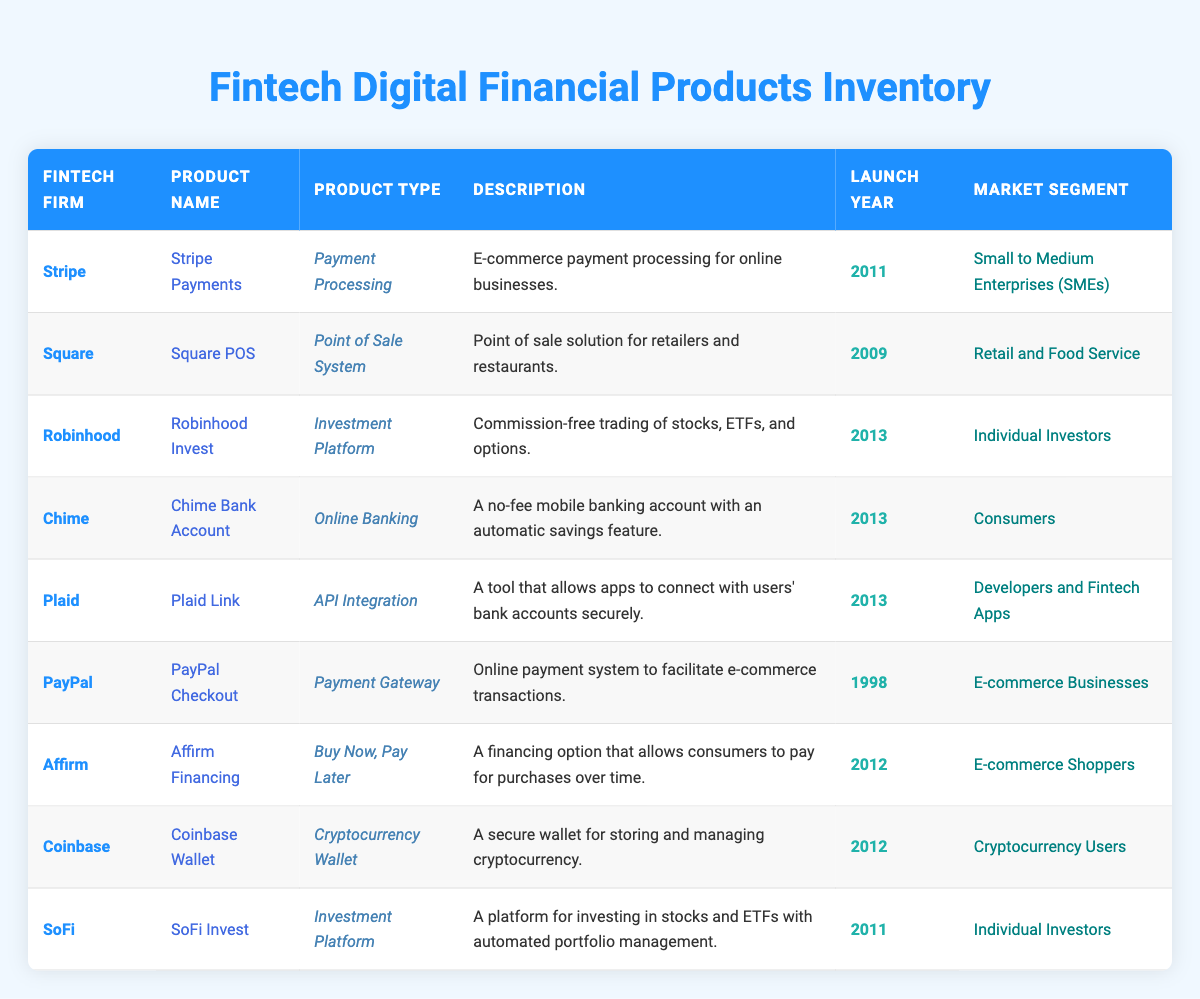What is the product type of Stripe's offering? There is one row for Stripe in the table. In that row, the "Product Type" column indicates "Payment Processing."
Answer: Payment Processing Which fintech firms offer investment platforms? The table contains two rows where the "Product Type" is "Investment Platform": Robinhood and SoFi.
Answer: Robinhood, SoFi How many products were launched in 2013? The table shows products launched in 2013 for Robinhood Invest, Chime Bank Account, and Plaid Link. Therefore, there are three products launched in that year.
Answer: 3 Is PayPal Checkout targeted towards individual investors? The table shows that "PayPal Checkout" is targeted at "E-commerce Businesses," not individual investors, so the statement is false.
Answer: No Which product type is offered by the most fintech firms in the table? The table shows various product types. Both "Payment Processing" (Stripe) and "Investment Platform" (Robinhood, SoFi) are offerings from a total of three fintech firms. However, "Investment Platform" represents more firms (2) than "Payment Processing" (1).
Answer: Investment Platform (2 firms) What is the average launch year for the products listed? The launch years are 1998, 2009, 2011, 2011, 2012, 2012, 2012, 2013, and 2013. Adding these gives 1998 + 2009 + 2011 + 2011 + 2012 + 2012 + 2012 + 2013 + 2013 =  2007.89. There are 9 products, thus the average year is 2007.89 rounded gives 2012.
Answer: 2012 Which fintech firm has the oldest product? By checking the "Launch Year" column, we see that PayPal Checkout launched in 1998, and that year is the earliest compared to others in the table.
Answer: PayPal Describe the market segment that Chime targets. In the row for Chime Bank Account, the "Market Segment" column shows "Consumers." This indicates that Chime's offerings are directed at individual consumers generally.
Answer: Consumers Which product helps in securing connections between apps and bank accounts? The table indicates that "Plaid Link" is an API integration tool designed for securely connecting apps with users' bank accounts.
Answer: Plaid Link 